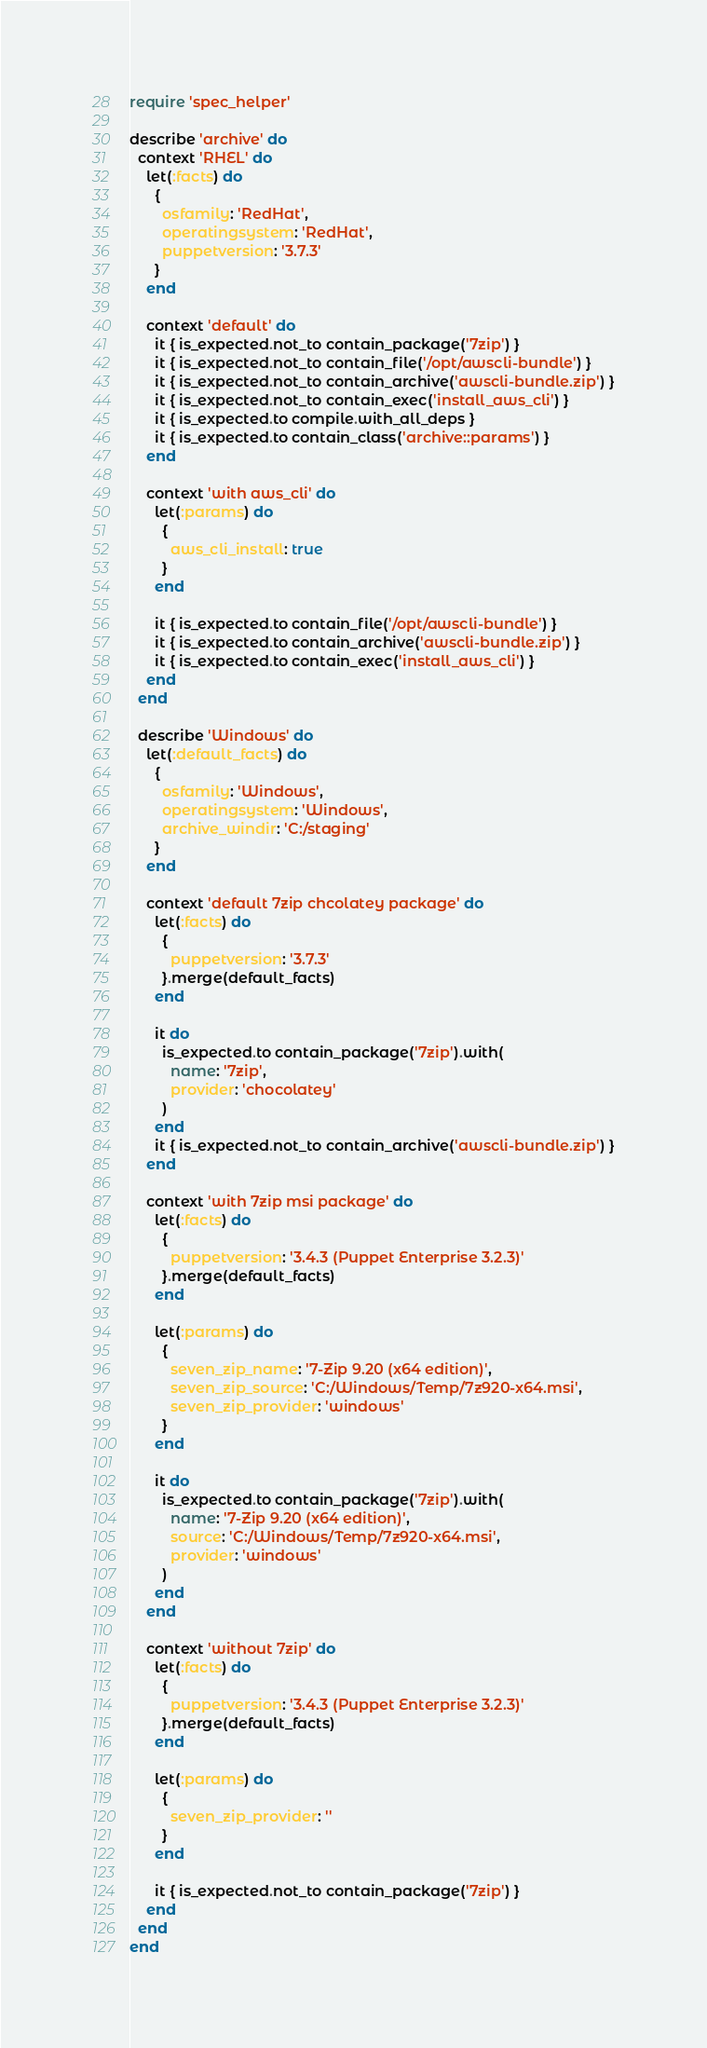<code> <loc_0><loc_0><loc_500><loc_500><_Ruby_>require 'spec_helper'

describe 'archive' do
  context 'RHEL' do
    let(:facts) do
      {
        osfamily: 'RedHat',
        operatingsystem: 'RedHat',
        puppetversion: '3.7.3'
      }
    end

    context 'default' do
      it { is_expected.not_to contain_package('7zip') }
      it { is_expected.not_to contain_file('/opt/awscli-bundle') }
      it { is_expected.not_to contain_archive('awscli-bundle.zip') }
      it { is_expected.not_to contain_exec('install_aws_cli') }
      it { is_expected.to compile.with_all_deps }
      it { is_expected.to contain_class('archive::params') }
    end

    context 'with aws_cli' do
      let(:params) do
        {
          aws_cli_install: true
        }
      end

      it { is_expected.to contain_file('/opt/awscli-bundle') }
      it { is_expected.to contain_archive('awscli-bundle.zip') }
      it { is_expected.to contain_exec('install_aws_cli') }
    end
  end

  describe 'Windows' do
    let(:default_facts) do
      {
        osfamily: 'Windows',
        operatingsystem: 'Windows',
        archive_windir: 'C:/staging'
      }
    end

    context 'default 7zip chcolatey package' do
      let(:facts) do
        {
          puppetversion: '3.7.3'
        }.merge(default_facts)
      end

      it do
        is_expected.to contain_package('7zip').with(
          name: '7zip',
          provider: 'chocolatey'
        )
      end
      it { is_expected.not_to contain_archive('awscli-bundle.zip') }
    end

    context 'with 7zip msi package' do
      let(:facts) do
        {
          puppetversion: '3.4.3 (Puppet Enterprise 3.2.3)'
        }.merge(default_facts)
      end

      let(:params) do
        {
          seven_zip_name: '7-Zip 9.20 (x64 edition)',
          seven_zip_source: 'C:/Windows/Temp/7z920-x64.msi',
          seven_zip_provider: 'windows'
        }
      end

      it do
        is_expected.to contain_package('7zip').with(
          name: '7-Zip 9.20 (x64 edition)',
          source: 'C:/Windows/Temp/7z920-x64.msi',
          provider: 'windows'
        )
      end
    end

    context 'without 7zip' do
      let(:facts) do
        {
          puppetversion: '3.4.3 (Puppet Enterprise 3.2.3)'
        }.merge(default_facts)
      end

      let(:params) do
        {
          seven_zip_provider: ''
        }
      end

      it { is_expected.not_to contain_package('7zip') }
    end
  end
end
</code> 